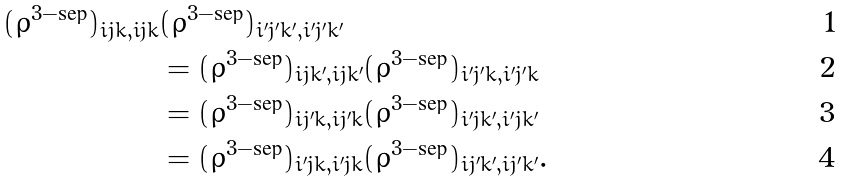<formula> <loc_0><loc_0><loc_500><loc_500>( \varrho ^ { 3 - \text {sep} } ) _ { i j k , i j k } & ( \varrho ^ { 3 - \text {sep} } ) _ { i ^ { \prime } j ^ { \prime } k ^ { \prime } , i ^ { \prime } j ^ { \prime } k ^ { \prime } } \\ & = ( \varrho ^ { 3 - \text {sep} } ) _ { i j k ^ { \prime } , i j k ^ { \prime } } ( \varrho ^ { 3 - \text {sep} } ) _ { i ^ { \prime } j ^ { \prime } k , i ^ { \prime } j ^ { \prime } k } \\ & = ( \varrho ^ { 3 - \text {sep} } ) _ { i j ^ { \prime } k , i j ^ { \prime } k } ( \varrho ^ { 3 - \text {sep} } ) _ { i ^ { \prime } j k ^ { \prime } , i ^ { \prime } j k ^ { \prime } } \\ & = ( \varrho ^ { 3 - \text {sep} } ) _ { i ^ { \prime } j k , i ^ { \prime } j k } ( \varrho ^ { 3 - \text {sep} } ) _ { i j ^ { \prime } k ^ { \prime } , i j ^ { \prime } k ^ { \prime } } .</formula> 